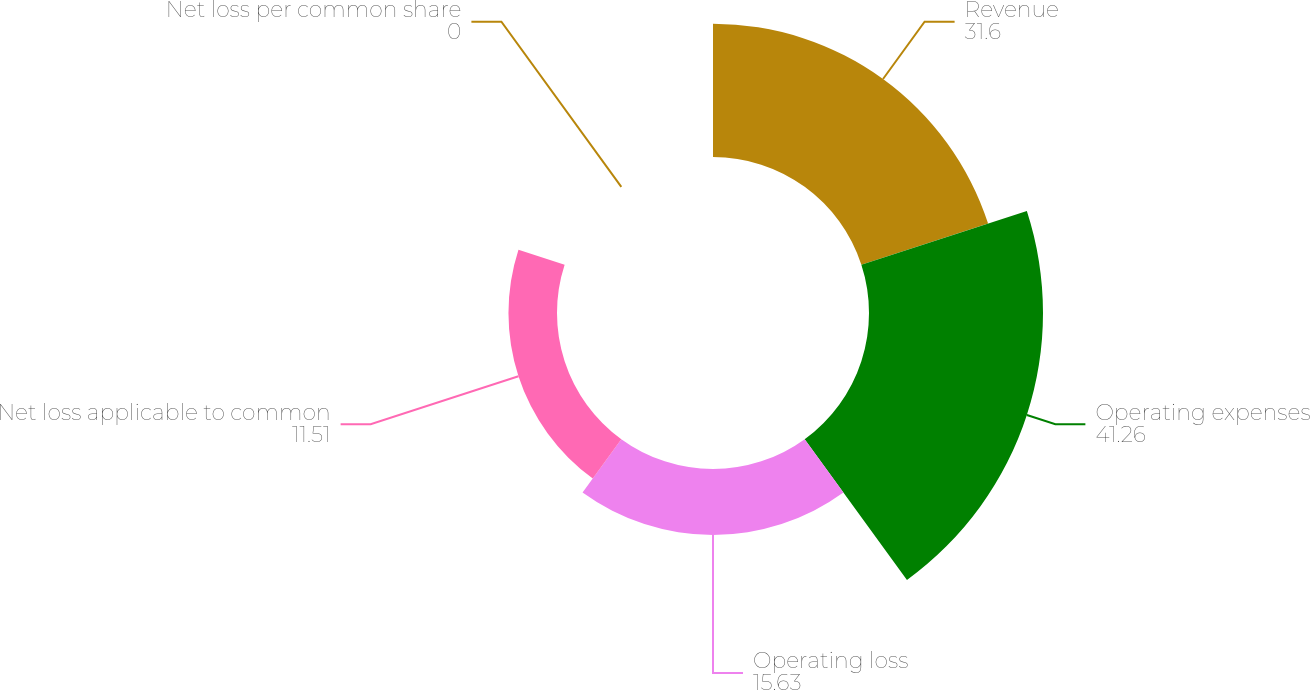Convert chart. <chart><loc_0><loc_0><loc_500><loc_500><pie_chart><fcel>Revenue<fcel>Operating expenses<fcel>Operating loss<fcel>Net loss applicable to common<fcel>Net loss per common share<nl><fcel>31.6%<fcel>41.26%<fcel>15.63%<fcel>11.51%<fcel>0.0%<nl></chart> 